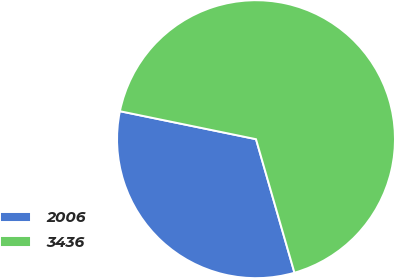<chart> <loc_0><loc_0><loc_500><loc_500><pie_chart><fcel>2006<fcel>3436<nl><fcel>32.69%<fcel>67.31%<nl></chart> 